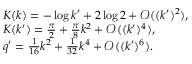Convert formula to latex. <formula><loc_0><loc_0><loc_500><loc_500>\begin{array} { l } { K ( k ) = - \log { k ^ { \prime } } + 2 \log { 2 } + \mathcal { O } ( ( k ^ { \prime } ) ^ { 2 } ) , } \\ { K ( k ^ { \prime } ) = \frac { \pi } { 2 } + \frac { \pi } { 8 } k ^ { 2 } + \mathcal { O } ( ( k ^ { \prime } ) ^ { 4 } ) , } \\ { q ^ { \prime } = \frac { 1 } { 1 6 } k ^ { 2 } + \frac { 1 } { 3 2 } k ^ { 4 } + \mathcal { O } ( ( k ^ { \prime } ) ^ { 6 } ) . } \end{array}</formula> 